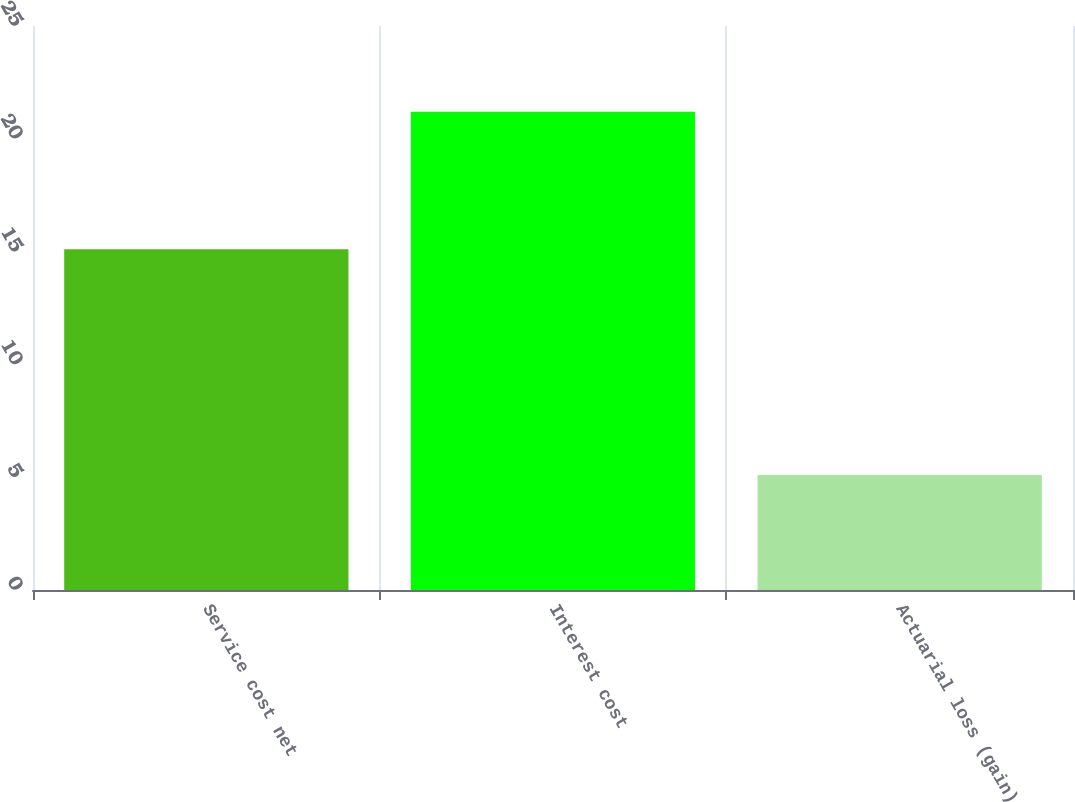<chart> <loc_0><loc_0><loc_500><loc_500><bar_chart><fcel>Service cost net<fcel>Interest cost<fcel>Actuarial loss (gain)<nl><fcel>15.1<fcel>21.2<fcel>5.1<nl></chart> 